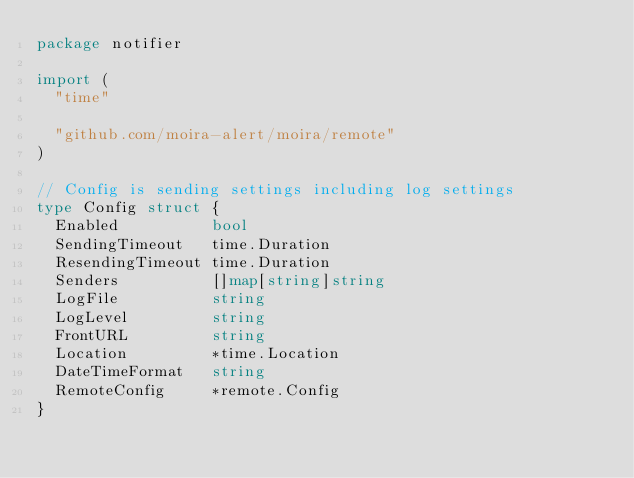<code> <loc_0><loc_0><loc_500><loc_500><_Go_>package notifier

import (
	"time"

	"github.com/moira-alert/moira/remote"
)

// Config is sending settings including log settings
type Config struct {
	Enabled          bool
	SendingTimeout   time.Duration
	ResendingTimeout time.Duration
	Senders          []map[string]string
	LogFile          string
	LogLevel         string
	FrontURL         string
	Location         *time.Location
	DateTimeFormat   string
	RemoteConfig     *remote.Config
}
</code> 